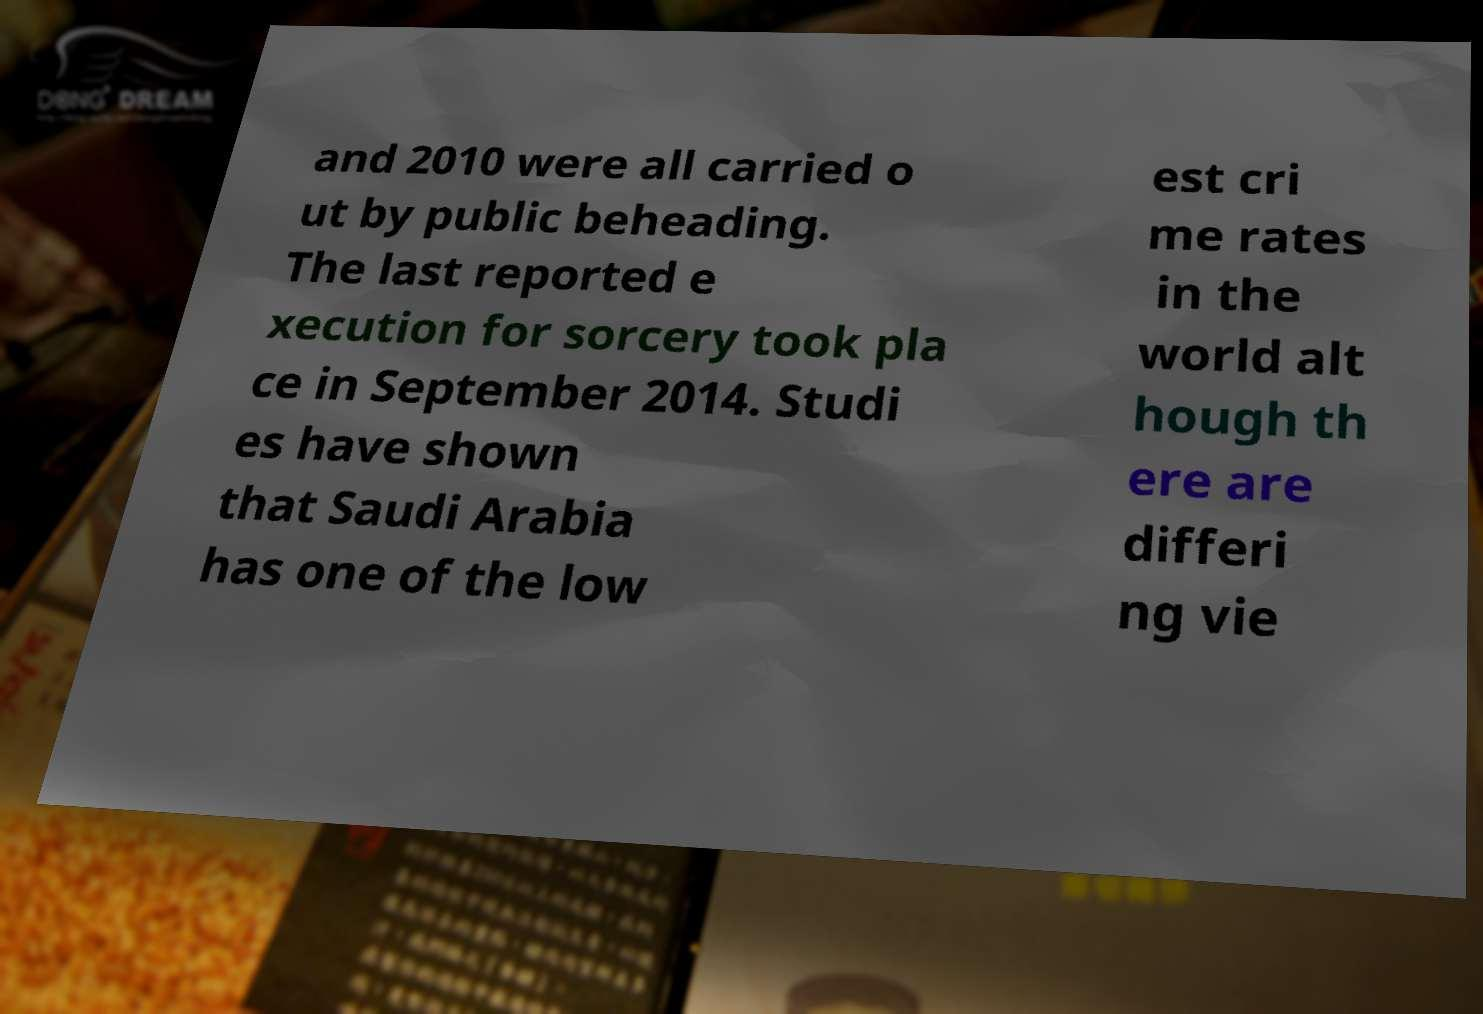I need the written content from this picture converted into text. Can you do that? and 2010 were all carried o ut by public beheading. The last reported e xecution for sorcery took pla ce in September 2014. Studi es have shown that Saudi Arabia has one of the low est cri me rates in the world alt hough th ere are differi ng vie 